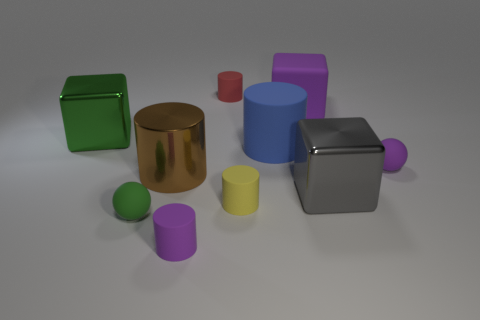Subtract all tiny yellow cylinders. How many cylinders are left? 4 Subtract all purple cylinders. How many cylinders are left? 4 Subtract all spheres. How many objects are left? 8 Add 4 large green objects. How many large green objects are left? 5 Add 3 tiny objects. How many tiny objects exist? 8 Subtract 0 gray cylinders. How many objects are left? 10 Subtract all brown balls. Subtract all yellow cubes. How many balls are left? 2 Subtract all gray blocks. Subtract all small green rubber blocks. How many objects are left? 9 